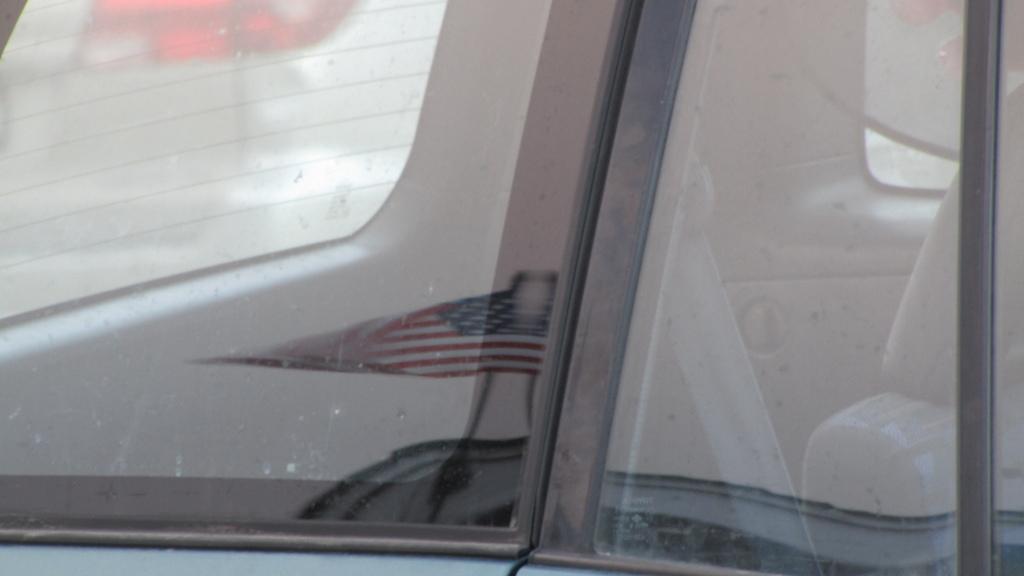In one or two sentences, can you explain what this image depicts? In this image we can see a mirror of a vehicle. On the mirror we can see a flag. 